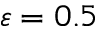<formula> <loc_0><loc_0><loc_500><loc_500>\varepsilon = 0 . 5</formula> 